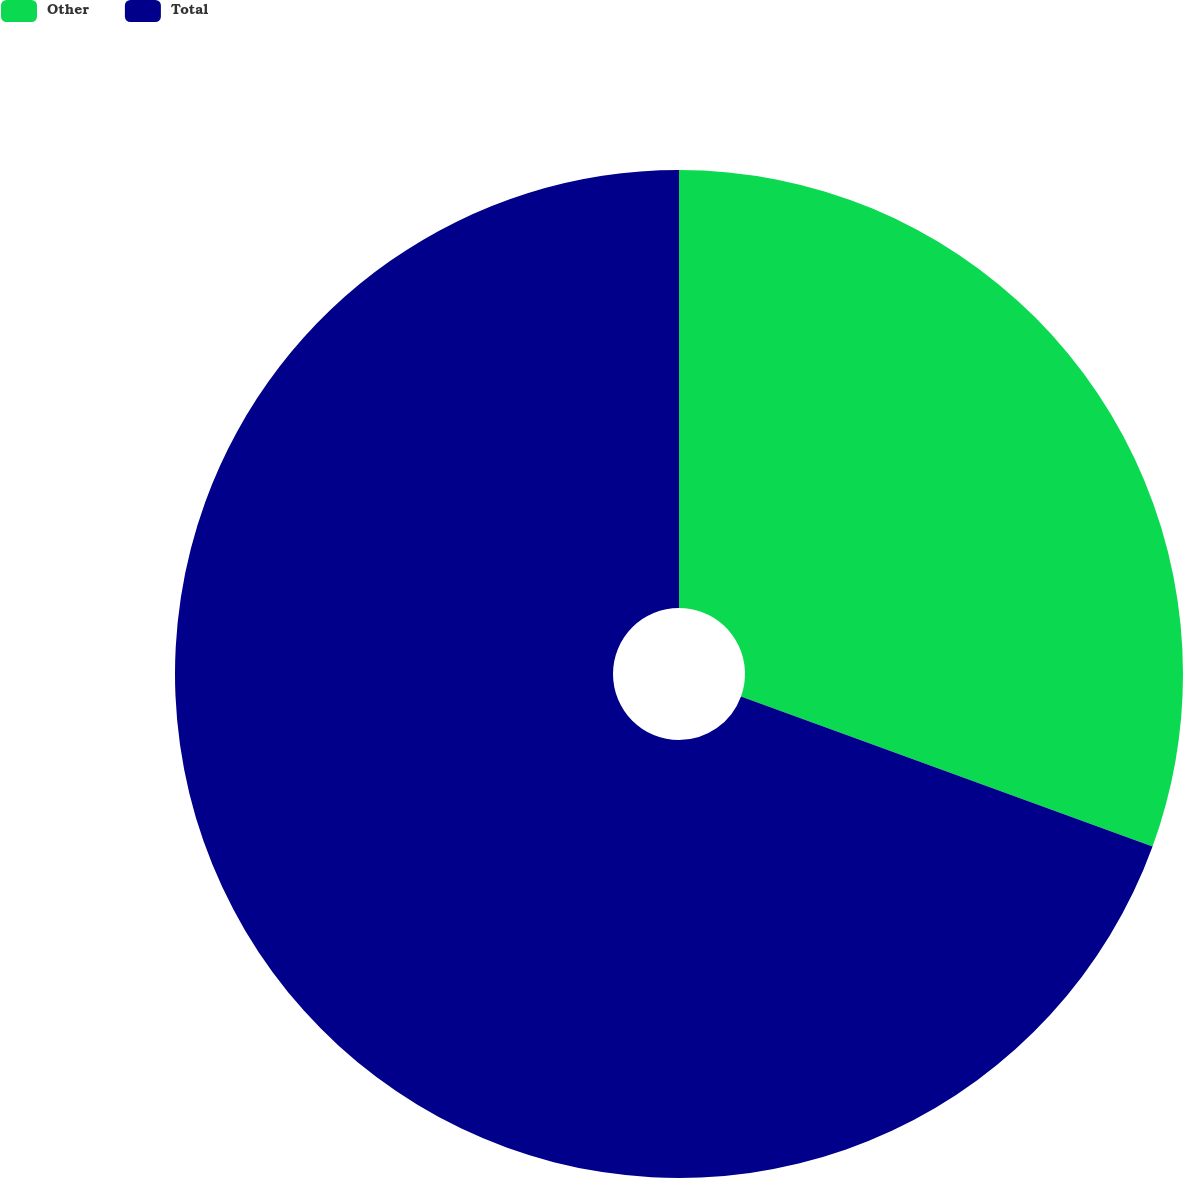Convert chart. <chart><loc_0><loc_0><loc_500><loc_500><pie_chart><fcel>Other<fcel>Total<nl><fcel>30.56%<fcel>69.44%<nl></chart> 